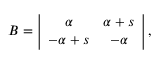<formula> <loc_0><loc_0><loc_500><loc_500>B = \left | \begin{array} { c c } { \alpha } & { \alpha + s } \\ { - \alpha + s } & { - \alpha } \end{array} \right | ,</formula> 